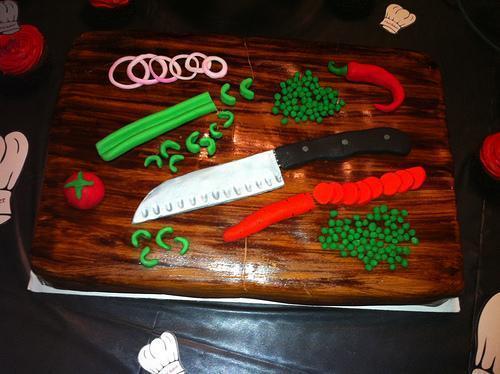How many knives are on the cake?
Give a very brief answer. 1. 